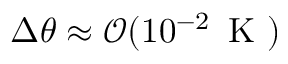Convert formula to latex. <formula><loc_0><loc_0><loc_500><loc_500>\Delta \theta \approx \mathcal { O } ( 1 0 ^ { - 2 } \, K )</formula> 